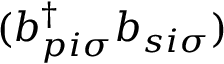<formula> <loc_0><loc_0><loc_500><loc_500>( b _ { p i \sigma } ^ { \dagger } b _ { s i \sigma } )</formula> 